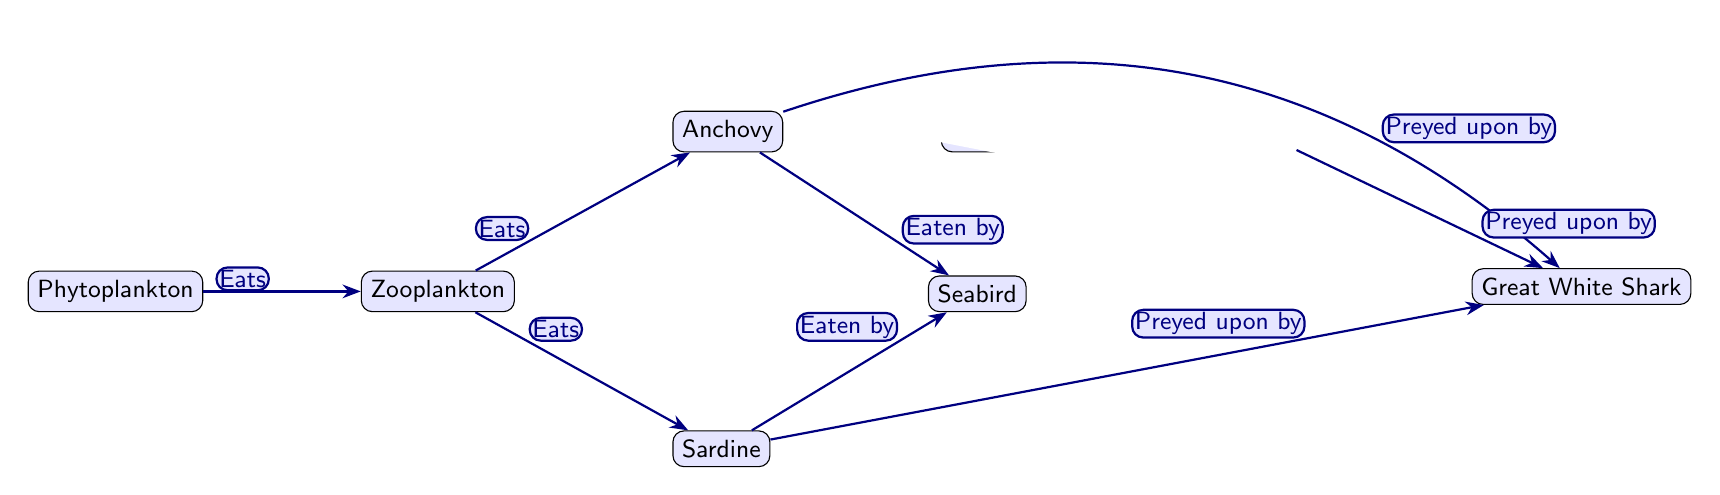What is the primary producer in this food chain? The food chain diagram shows that phytoplankton is positioned at the starting point, which is typical for primary producers that generate energy from sunlight.
Answer: Phytoplankton How many types of prey are there for the Great White Shark? To find the prey for the Great White Shark, I count the edges leading from other nodes to the Great White Shark. I see there are three paths: from Anchovy, Sardine, and Sea Lion.
Answer: 3 Which organism is eaten by both Anchovy and Sardine? Reviewing the relationships in the diagram, I identify that Zooplankton is the intermediary node that is consumed by both Anchovy and Sardine.
Answer: Zooplankton What is the role of Jellyfish in this food chain? Jellyfish is shown to be a prey item for Sea Lion in the diagram, indicating that it occupies the position of prey in the food chain.
Answer: Prey Which organism eats Zooplankton? The diagram clearly states that phytoplankton is consumed by Zooplankton; thus, I see that Zooplankton is a secondary consumer.
Answer: Phytoplankton How many organisms are considered predators in this diagram? By examining the edges leading toward the nodes, I count Anchovy, Sardine, Sea Lion, and Great White Shark as predators, giving a total of four.
Answer: 4 Who are the direct competitors for food beside Sea Lion? The diagram reveals that Sea Lion competes with Great White Shark, considering both occupy similar top predator roles, as they feed on similar prey like Jellyfish and smaller fish.
Answer: Great White Shark What flows from Zooplankton to Anchovy in the diagram? The edge labeled "Eats" between the nodes indicates that Zooplankton consumes Anchovy, linking them in the food chain's progression.
Answer: Eats Is Seabird a predator or a prey in this food chain? Reviewing the diagram shows Seabird is positioned at the top, indicating it is a predator as it eats both Anchovy and Sardine.
Answer: Predator 